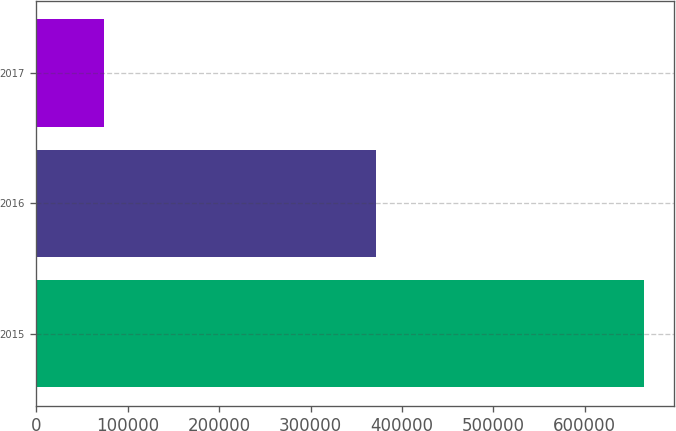Convert chart. <chart><loc_0><loc_0><loc_500><loc_500><bar_chart><fcel>2015<fcel>2016<fcel>2017<nl><fcel>665000<fcel>372000<fcel>74000<nl></chart> 